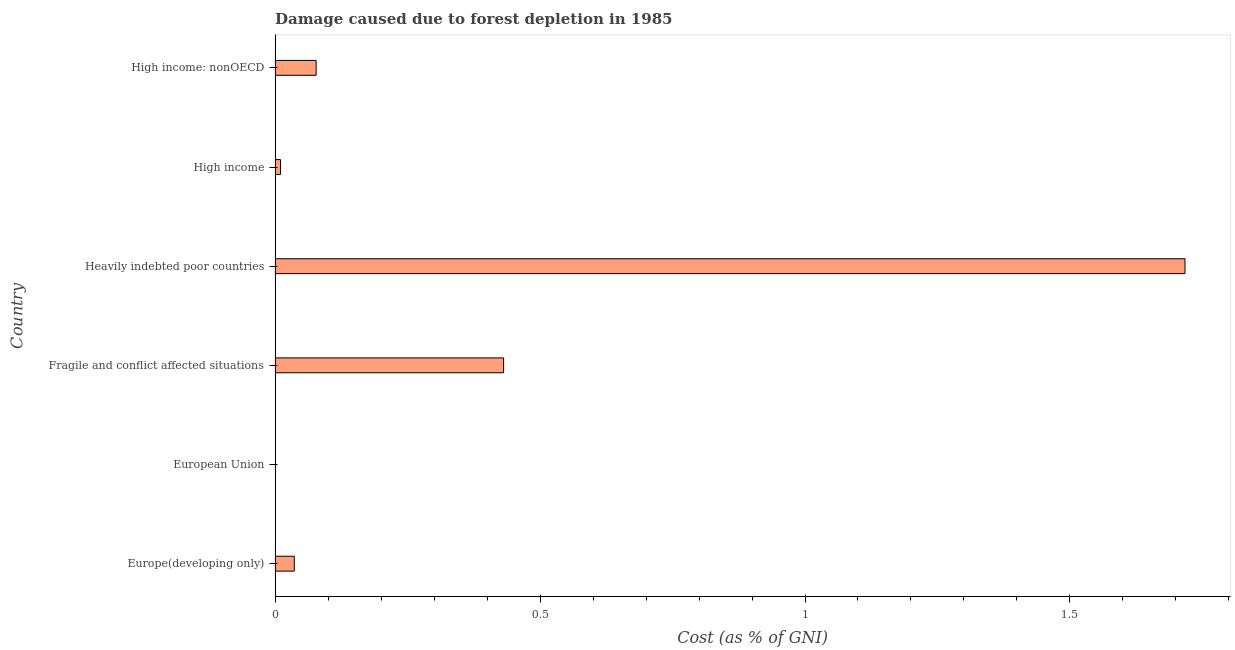What is the title of the graph?
Keep it short and to the point. Damage caused due to forest depletion in 1985. What is the label or title of the X-axis?
Offer a terse response. Cost (as % of GNI). What is the damage caused due to forest depletion in Europe(developing only)?
Your answer should be very brief. 0.04. Across all countries, what is the maximum damage caused due to forest depletion?
Give a very brief answer. 1.72. Across all countries, what is the minimum damage caused due to forest depletion?
Ensure brevity in your answer.  0. In which country was the damage caused due to forest depletion maximum?
Provide a short and direct response. Heavily indebted poor countries. What is the sum of the damage caused due to forest depletion?
Make the answer very short. 2.27. What is the difference between the damage caused due to forest depletion in High income and High income: nonOECD?
Your answer should be very brief. -0.07. What is the average damage caused due to forest depletion per country?
Make the answer very short. 0.38. What is the median damage caused due to forest depletion?
Provide a succinct answer. 0.06. What is the ratio of the damage caused due to forest depletion in Europe(developing only) to that in High income?
Make the answer very short. 3.5. What is the difference between the highest and the second highest damage caused due to forest depletion?
Your answer should be very brief. 1.29. Is the sum of the damage caused due to forest depletion in European Union and High income: nonOECD greater than the maximum damage caused due to forest depletion across all countries?
Your answer should be very brief. No. What is the difference between the highest and the lowest damage caused due to forest depletion?
Give a very brief answer. 1.72. How many bars are there?
Provide a short and direct response. 6. How many countries are there in the graph?
Provide a short and direct response. 6. What is the difference between two consecutive major ticks on the X-axis?
Offer a terse response. 0.5. What is the Cost (as % of GNI) of Europe(developing only)?
Make the answer very short. 0.04. What is the Cost (as % of GNI) in European Union?
Ensure brevity in your answer.  0. What is the Cost (as % of GNI) of Fragile and conflict affected situations?
Provide a succinct answer. 0.43. What is the Cost (as % of GNI) in Heavily indebted poor countries?
Offer a terse response. 1.72. What is the Cost (as % of GNI) in High income?
Your response must be concise. 0.01. What is the Cost (as % of GNI) of High income: nonOECD?
Provide a succinct answer. 0.08. What is the difference between the Cost (as % of GNI) in Europe(developing only) and European Union?
Your response must be concise. 0.04. What is the difference between the Cost (as % of GNI) in Europe(developing only) and Fragile and conflict affected situations?
Provide a succinct answer. -0.4. What is the difference between the Cost (as % of GNI) in Europe(developing only) and Heavily indebted poor countries?
Ensure brevity in your answer.  -1.68. What is the difference between the Cost (as % of GNI) in Europe(developing only) and High income?
Keep it short and to the point. 0.03. What is the difference between the Cost (as % of GNI) in Europe(developing only) and High income: nonOECD?
Offer a terse response. -0.04. What is the difference between the Cost (as % of GNI) in European Union and Fragile and conflict affected situations?
Your response must be concise. -0.43. What is the difference between the Cost (as % of GNI) in European Union and Heavily indebted poor countries?
Give a very brief answer. -1.72. What is the difference between the Cost (as % of GNI) in European Union and High income?
Your response must be concise. -0.01. What is the difference between the Cost (as % of GNI) in European Union and High income: nonOECD?
Provide a short and direct response. -0.08. What is the difference between the Cost (as % of GNI) in Fragile and conflict affected situations and Heavily indebted poor countries?
Give a very brief answer. -1.29. What is the difference between the Cost (as % of GNI) in Fragile and conflict affected situations and High income?
Your answer should be very brief. 0.42. What is the difference between the Cost (as % of GNI) in Fragile and conflict affected situations and High income: nonOECD?
Keep it short and to the point. 0.35. What is the difference between the Cost (as % of GNI) in Heavily indebted poor countries and High income?
Make the answer very short. 1.71. What is the difference between the Cost (as % of GNI) in Heavily indebted poor countries and High income: nonOECD?
Ensure brevity in your answer.  1.64. What is the difference between the Cost (as % of GNI) in High income and High income: nonOECD?
Offer a very short reply. -0.07. What is the ratio of the Cost (as % of GNI) in Europe(developing only) to that in European Union?
Your answer should be very brief. 69.21. What is the ratio of the Cost (as % of GNI) in Europe(developing only) to that in Fragile and conflict affected situations?
Make the answer very short. 0.08. What is the ratio of the Cost (as % of GNI) in Europe(developing only) to that in Heavily indebted poor countries?
Your answer should be compact. 0.02. What is the ratio of the Cost (as % of GNI) in Europe(developing only) to that in High income?
Provide a succinct answer. 3.5. What is the ratio of the Cost (as % of GNI) in Europe(developing only) to that in High income: nonOECD?
Give a very brief answer. 0.47. What is the ratio of the Cost (as % of GNI) in European Union to that in High income?
Provide a succinct answer. 0.05. What is the ratio of the Cost (as % of GNI) in European Union to that in High income: nonOECD?
Your response must be concise. 0.01. What is the ratio of the Cost (as % of GNI) in Fragile and conflict affected situations to that in Heavily indebted poor countries?
Your answer should be very brief. 0.25. What is the ratio of the Cost (as % of GNI) in Fragile and conflict affected situations to that in High income?
Offer a terse response. 41.67. What is the ratio of the Cost (as % of GNI) in Fragile and conflict affected situations to that in High income: nonOECD?
Offer a very short reply. 5.57. What is the ratio of the Cost (as % of GNI) in Heavily indebted poor countries to that in High income?
Give a very brief answer. 165.93. What is the ratio of the Cost (as % of GNI) in Heavily indebted poor countries to that in High income: nonOECD?
Your answer should be compact. 22.16. What is the ratio of the Cost (as % of GNI) in High income to that in High income: nonOECD?
Keep it short and to the point. 0.13. 